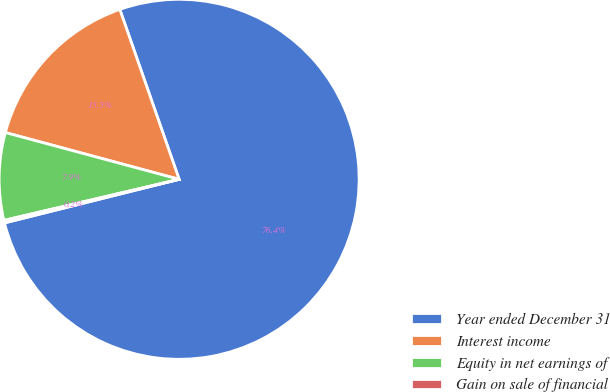Convert chart to OTSL. <chart><loc_0><loc_0><loc_500><loc_500><pie_chart><fcel>Year ended December 31<fcel>Interest income<fcel>Equity in net earnings of<fcel>Gain on sale of financial<nl><fcel>76.45%<fcel>15.47%<fcel>7.85%<fcel>0.23%<nl></chart> 